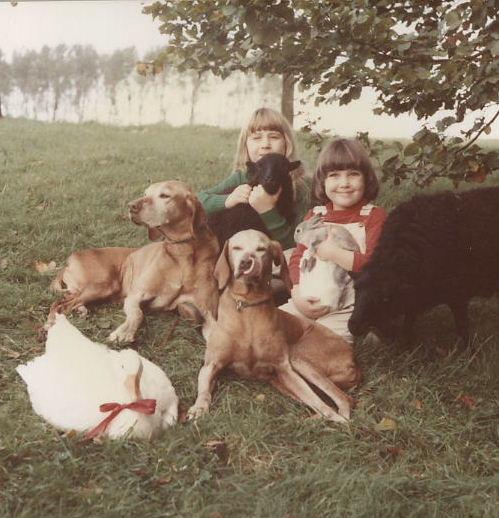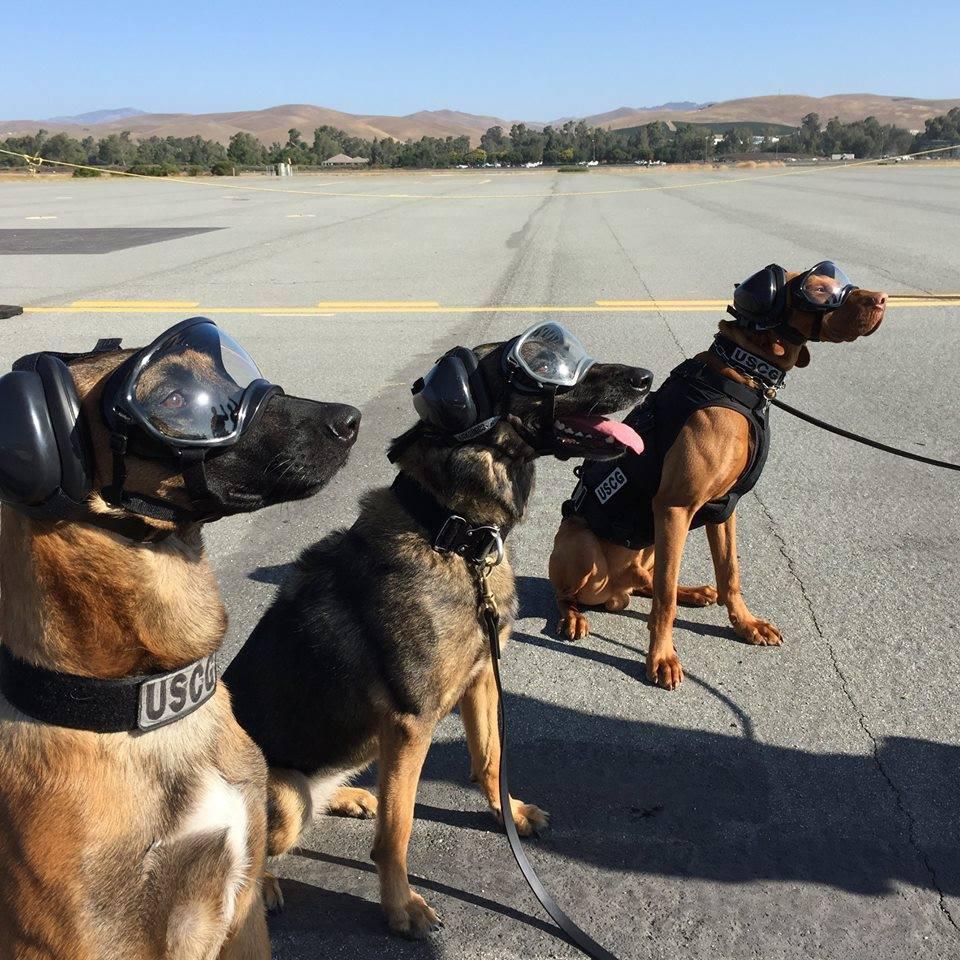The first image is the image on the left, the second image is the image on the right. Evaluate the accuracy of this statement regarding the images: "In one of the images hunters posing with their guns and prey.". Is it true? Answer yes or no. No. The first image is the image on the left, the second image is the image on the right. Evaluate the accuracy of this statement regarding the images: "Nine or more mammals are present.". Is it true? Answer yes or no. Yes. 